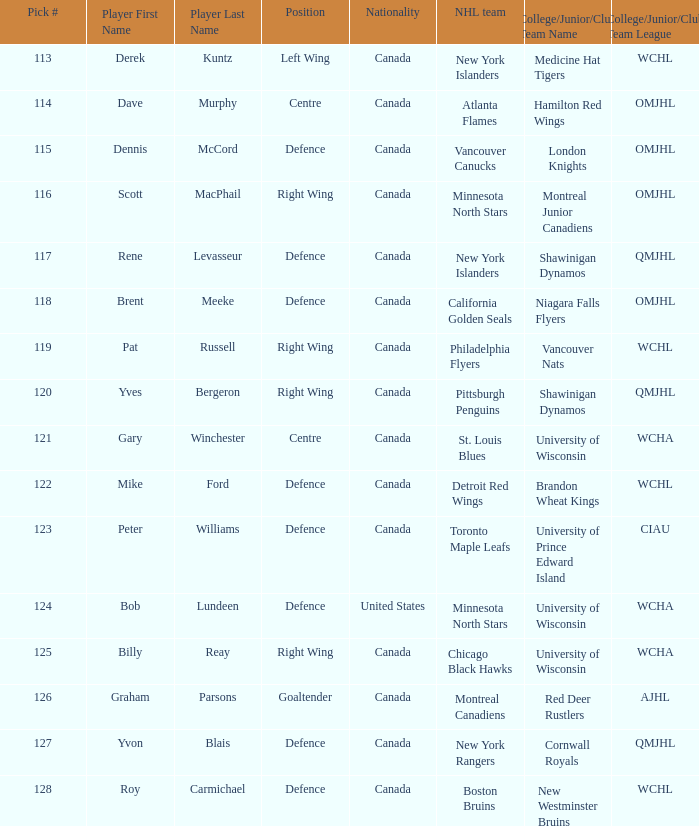Name the college/junior/club team for left wing Medicine Hat Tigers (WCHL). 